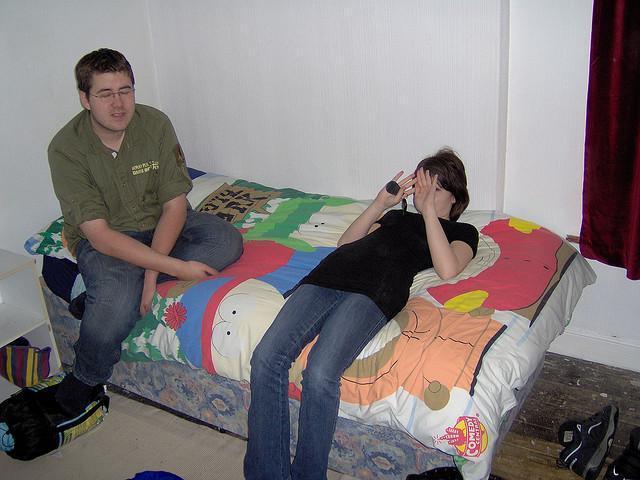How many people are in this picture?
Give a very brief answer. 2. How many people are there?
Give a very brief answer. 2. 